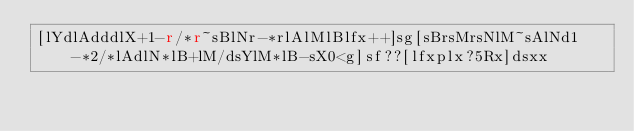Convert code to text. <code><loc_0><loc_0><loc_500><loc_500><_dc_>[lYdlAdddlX+1-r/*r~sBlNr-*rlAlMlBlfx++]sg[sBrsMrsNlM~sAlNd1-*2/*lAdlN*lB+lM/dsYlM*lB-sX0<g]sf??[lfxplx?5Rx]dsxx</code> 